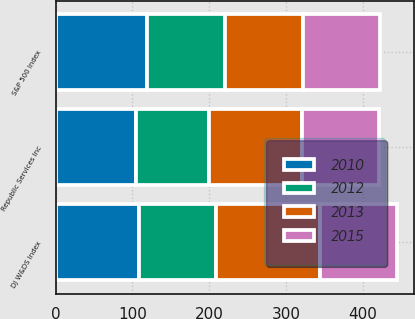Convert chart. <chart><loc_0><loc_0><loc_500><loc_500><stacked_bar_chart><ecel><fcel>Republic Services Inc<fcel>S&P 500 Index<fcel>DJ W&DS Index<nl><fcel>2015<fcel>100<fcel>100<fcel>100<nl><fcel>2012<fcel>94.96<fcel>102.11<fcel>100.18<nl><fcel>2010<fcel>104.47<fcel>118.45<fcel>108.7<nl><fcel>2013<fcel>121.84<fcel>102.11<fcel>135.8<nl></chart> 